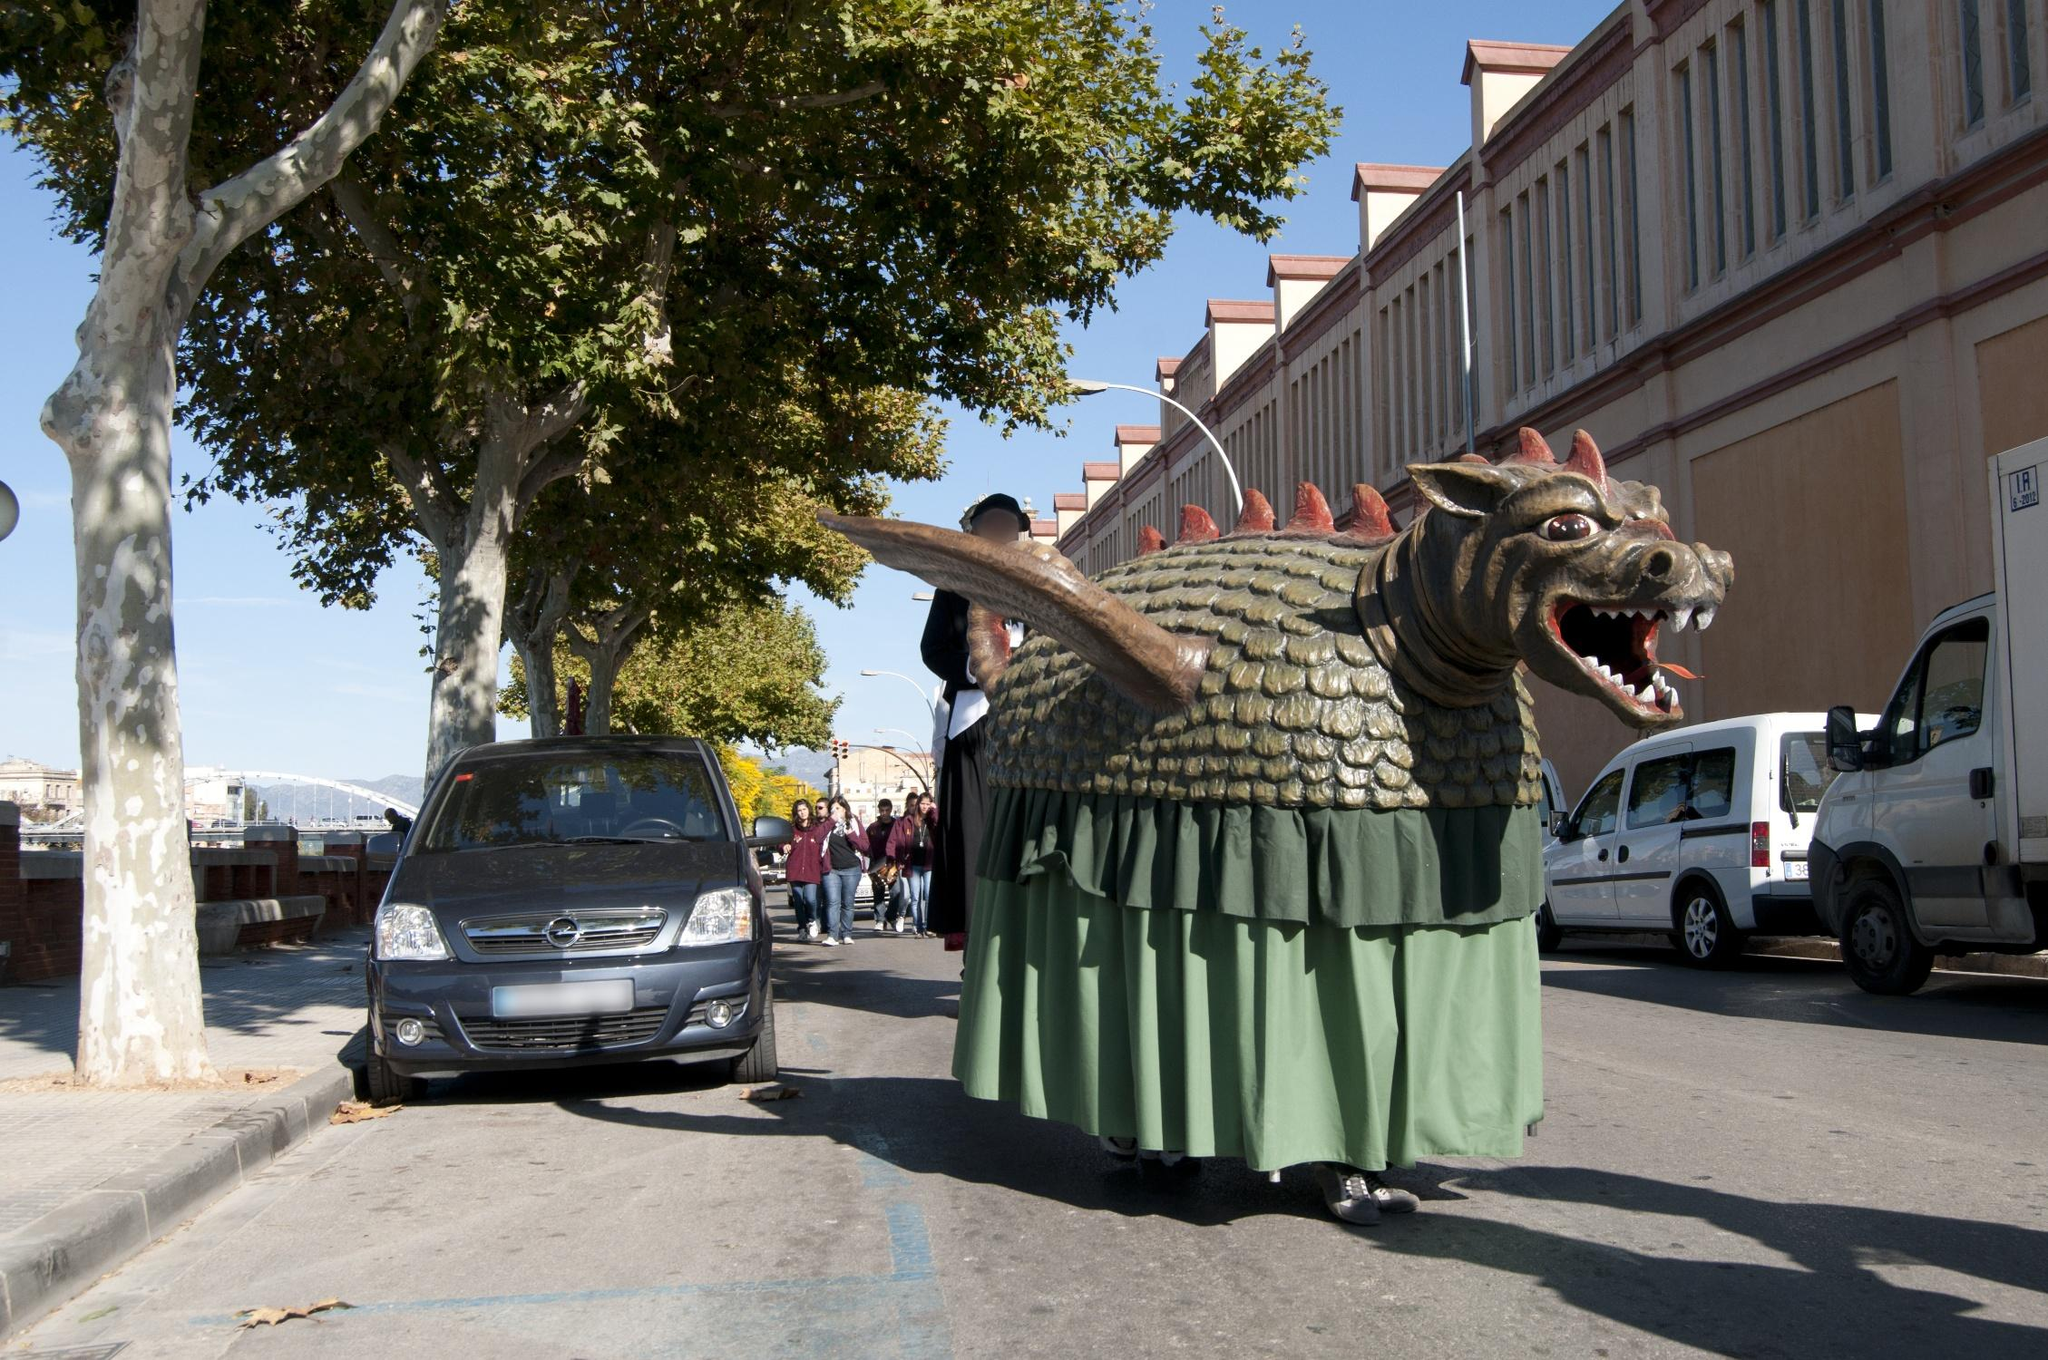Analyze the image in a comprehensive and detailed manner. This image captures a lively and colorful scene from a street in Barcelona, Spain, likely during a festive event or parade. Dominating the image is a large, intricately crafted dragon float with green fabric scales, red spikes along its back, and an open mouth that gives it a roaring appearance. The dragon is being guided down the street by individuals dressed in matching green outfits, blending seamlessly with the float. The street itself is lined with tall trees and traditional Spanish buildings, adding depth and a sense of place to the scene. In the foreground, a modern blue car is parked along the sidewalk, juxtaposing the traditional celebratory elements with contemporary life. The clear blue sky suggests a bright and sunny day, further adding to the festive atmosphere. Overall, the image is a vibrant depiction of cultural celebration, where tradition and modernity coalesce. 